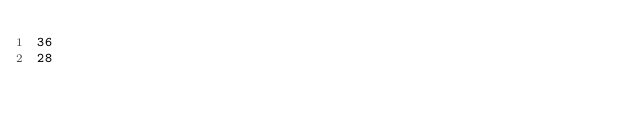<code> <loc_0><loc_0><loc_500><loc_500><_SQL_>36
28</code> 